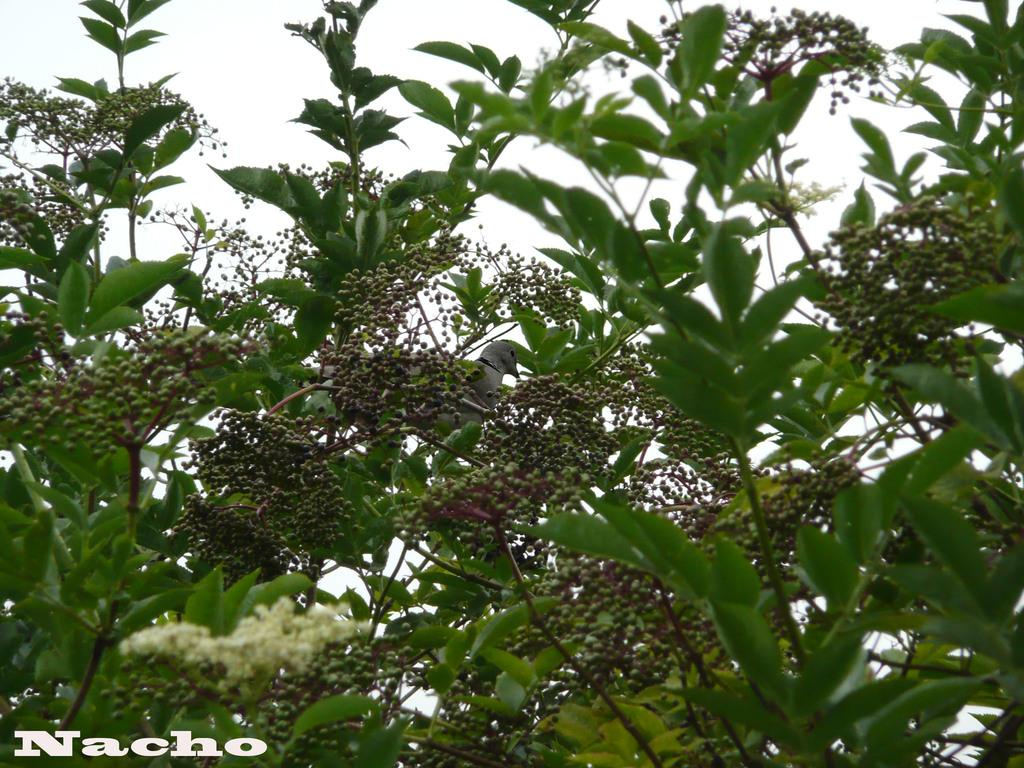What can be seen in the bottom left corner of the image? There is a watermark in the bottom left corner of the image. What type of vegetation is in the middle of the image? There are trees in the middle of the image. What is visible at the top of the image? The sky is visible at the top of the image. Can you tell me how many cherries are hanging from the trees in the image? There are no cherries present in the image; it features trees without any visible fruit. What type of bird can be seen perched on the grass in the image? There is no bird or grass present in the image; it only features trees and a sky. 